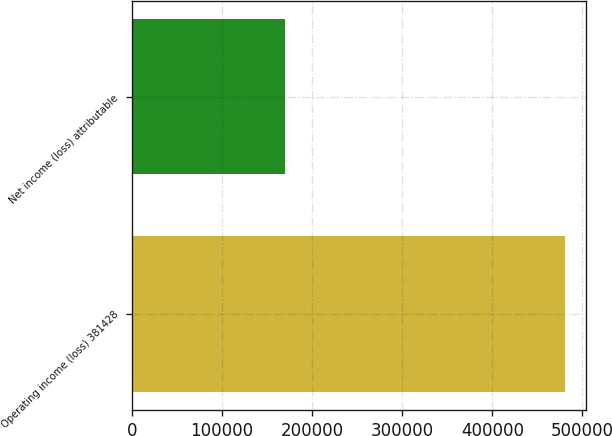<chart> <loc_0><loc_0><loc_500><loc_500><bar_chart><fcel>Operating income (loss) 381428<fcel>Net income (loss) attributable<nl><fcel>480548<fcel>170477<nl></chart> 